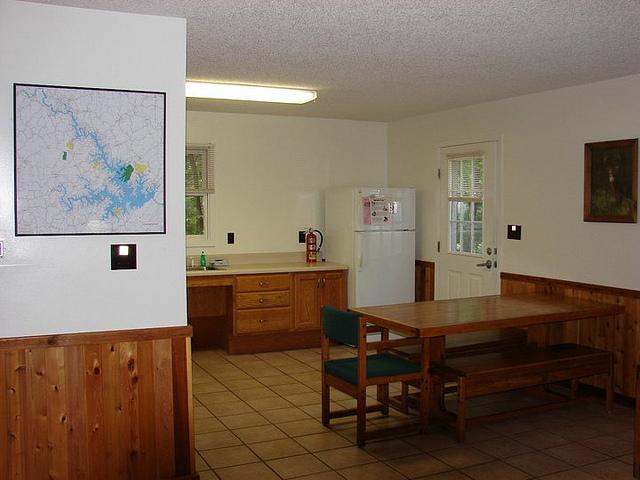Does this window arrangement allow for ample sunlight?
Keep it brief. No. What color is the counter?
Answer briefly. White. How many chairs are in the scene?
Give a very brief answer. 1. Is the front part of the room carpeted?
Write a very short answer. No. How is this room being lit?
Keep it brief. Fluorescent light. What side of the room is the door located?
Concise answer only. Right. Is the floor made of wood?
Give a very brief answer. No. How many entry doors do you see?
Be succinct. 1. Is there food on the table?
Concise answer only. No. Where is the fire extinguisher?
Be succinct. On counter. Is the floor tile or wood?
Concise answer only. Tile. Are there any people in the room?
Keep it brief. No. Where is the dining table?
Give a very brief answer. Kitchen. What is the material of the flooring?
Give a very brief answer. Tile. What is on the refrigerator?
Give a very brief answer. Magnets. What are the chairs made of?
Write a very short answer. Wood. Is this a nice house?
Quick response, please. Yes. Is there a tripping hazard in the room?
Quick response, please. No. How many chairs are there at the table?
Quick response, please. 1. How many chairs are in the photo?
Quick response, please. 1. Do you like this kitchen?
Short answer required. No. What is this room being used for?
Write a very short answer. Kitchen. Is the door open or closed?
Answer briefly. Closed. Is there a pretty decoration on the table?
Short answer required. No. Is the floor wood?
Give a very brief answer. No. Is this kitchen roomy?
Quick response, please. Yes. What kind of a flooring is there?
Write a very short answer. Tile. What room is this?
Keep it brief. Kitchen. Is the table cleared?
Be succinct. Yes. Is the refrigerator stainless steel?
Give a very brief answer. No. How many chairs are there?
Quick response, please. 1. What color are the walls?
Answer briefly. White. How many chairs are visible in the dining room?
Keep it brief. 1. Can you spot the guy in the mirror?
Quick response, please. No. What material is the floor in this scene made of?
Keep it brief. Tile. What type of floor is in this room?
Concise answer only. Tile. How many lights are over the island?
Write a very short answer. 1. What room is to the right?
Keep it brief. Dining room. Is there anything on the table?
Give a very brief answer. No. What color are the chairs at the table?
Give a very brief answer. Green. Are there any windows in this image?
Short answer required. Yes. 